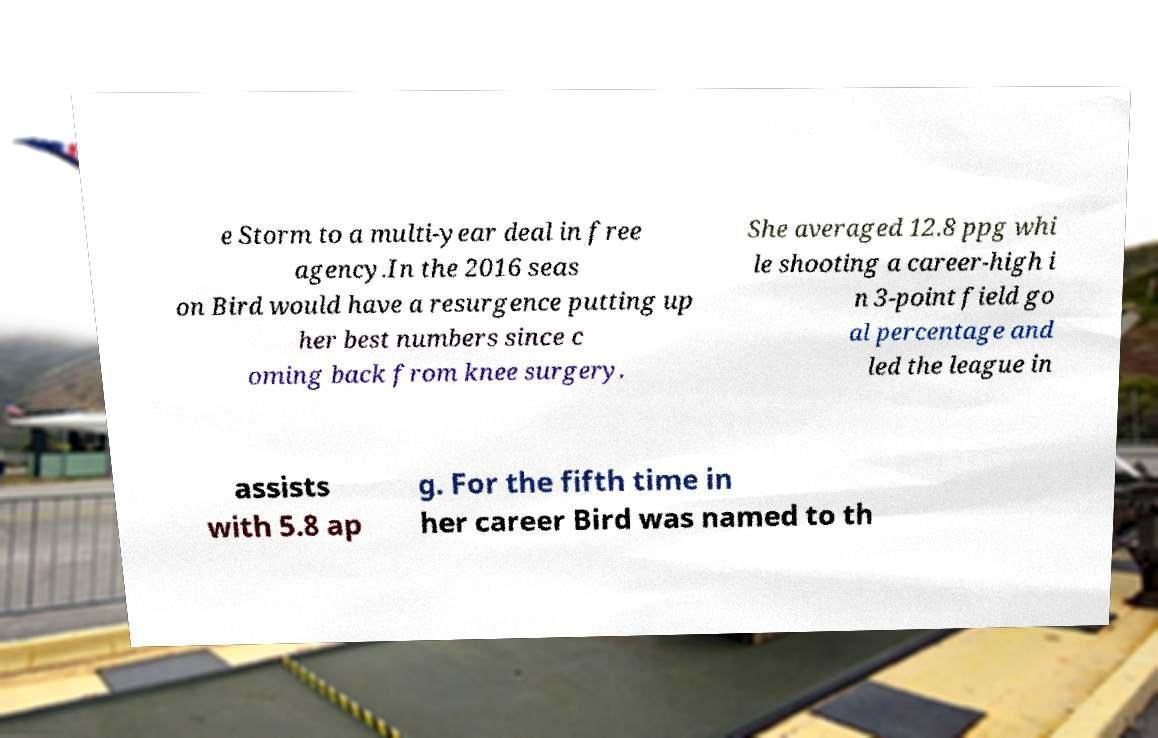Please read and relay the text visible in this image. What does it say? e Storm to a multi-year deal in free agency.In the 2016 seas on Bird would have a resurgence putting up her best numbers since c oming back from knee surgery. She averaged 12.8 ppg whi le shooting a career-high i n 3-point field go al percentage and led the league in assists with 5.8 ap g. For the fifth time in her career Bird was named to th 